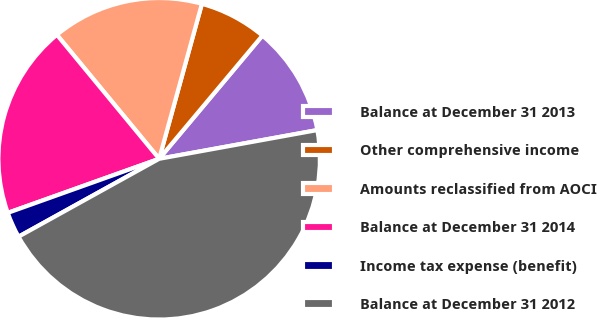Convert chart. <chart><loc_0><loc_0><loc_500><loc_500><pie_chart><fcel>Balance at December 31 2013<fcel>Other comprehensive income<fcel>Amounts reclassified from AOCI<fcel>Balance at December 31 2014<fcel>Income tax expense (benefit)<fcel>Balance at December 31 2012<nl><fcel>11.04%<fcel>6.82%<fcel>15.26%<fcel>19.48%<fcel>2.59%<fcel>44.81%<nl></chart> 